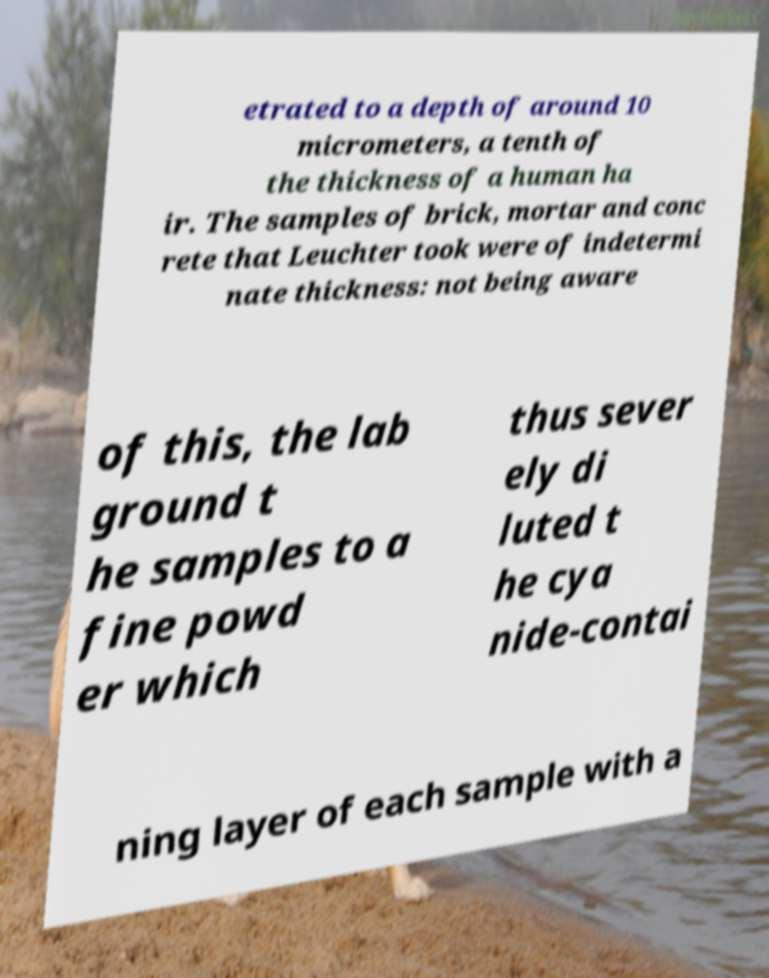There's text embedded in this image that I need extracted. Can you transcribe it verbatim? etrated to a depth of around 10 micrometers, a tenth of the thickness of a human ha ir. The samples of brick, mortar and conc rete that Leuchter took were of indetermi nate thickness: not being aware of this, the lab ground t he samples to a fine powd er which thus sever ely di luted t he cya nide-contai ning layer of each sample with a 